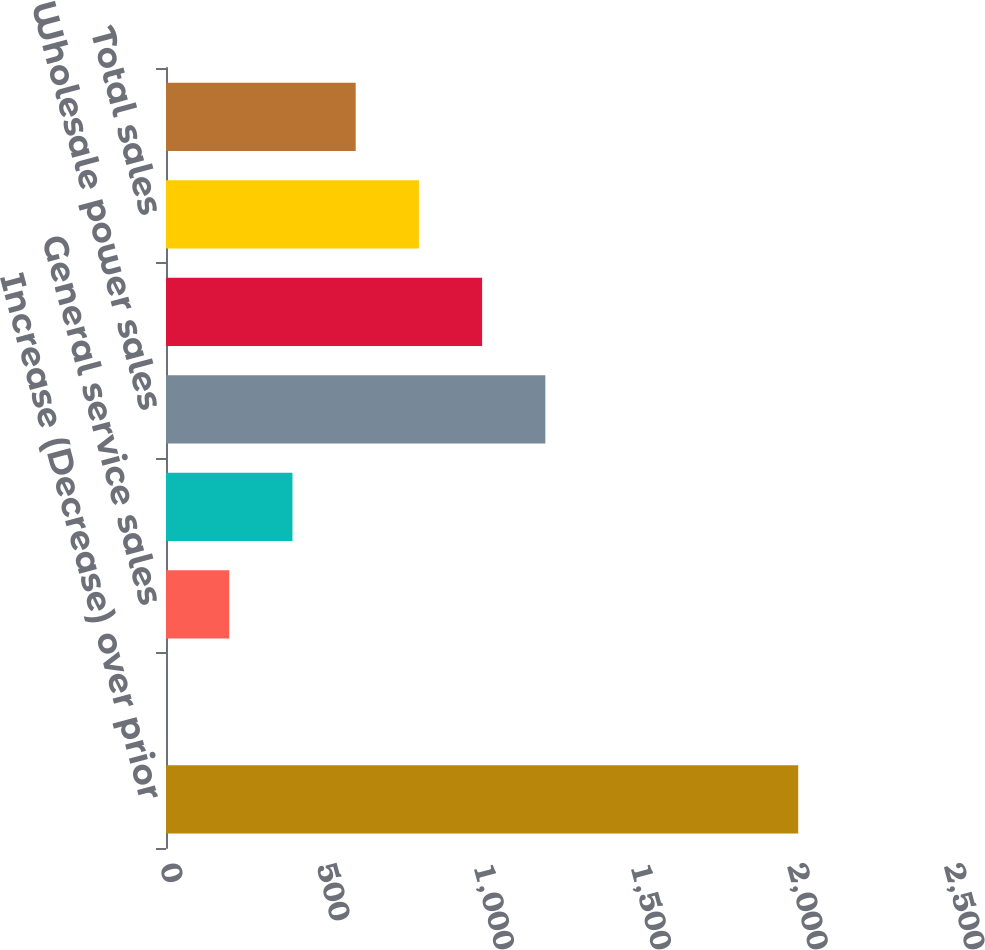Convert chart to OTSL. <chart><loc_0><loc_0><loc_500><loc_500><bar_chart><fcel>Increase (Decrease) over prior<fcel>Residential sales<fcel>General service sales<fcel>Industrial sales<fcel>Wholesale power sales<fcel>Joint dispatch sales<fcel>Total sales<fcel>Average number of customers<nl><fcel>2016<fcel>0.1<fcel>201.69<fcel>403.28<fcel>1209.64<fcel>1008.05<fcel>806.46<fcel>604.87<nl></chart> 